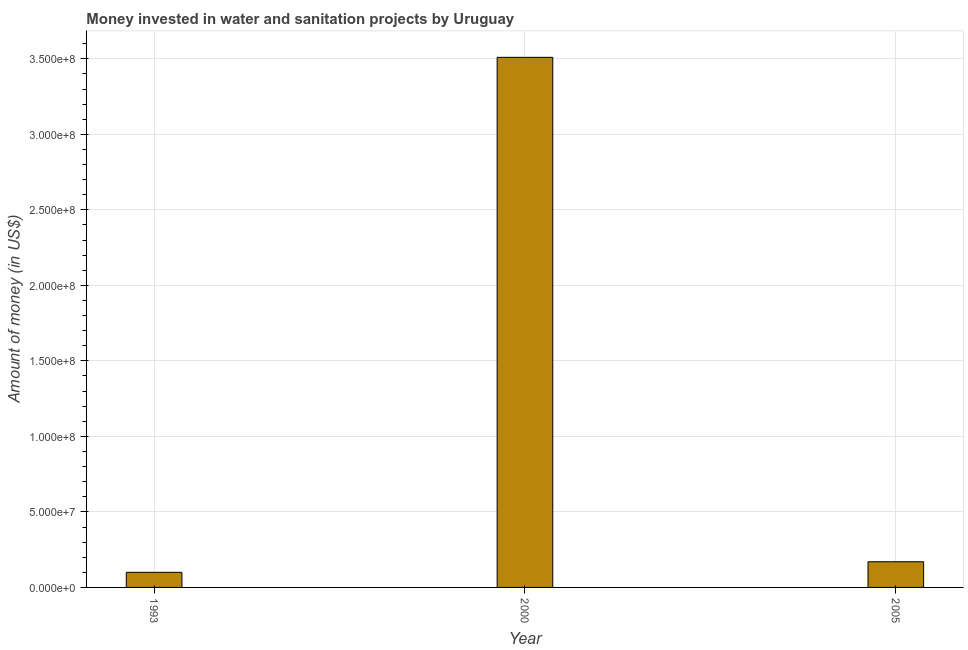Does the graph contain any zero values?
Your response must be concise. No. What is the title of the graph?
Provide a succinct answer. Money invested in water and sanitation projects by Uruguay. What is the label or title of the Y-axis?
Provide a short and direct response. Amount of money (in US$). What is the investment in 2000?
Your answer should be very brief. 3.51e+08. Across all years, what is the maximum investment?
Provide a short and direct response. 3.51e+08. In which year was the investment maximum?
Your response must be concise. 2000. In which year was the investment minimum?
Keep it short and to the point. 1993. What is the sum of the investment?
Keep it short and to the point. 3.78e+08. What is the difference between the investment in 1993 and 2000?
Your answer should be compact. -3.41e+08. What is the average investment per year?
Ensure brevity in your answer.  1.26e+08. What is the median investment?
Your answer should be compact. 1.70e+07. In how many years, is the investment greater than 300000000 US$?
Your response must be concise. 1. What is the ratio of the investment in 1993 to that in 2005?
Offer a very short reply. 0.59. Is the investment in 1993 less than that in 2000?
Give a very brief answer. Yes. What is the difference between the highest and the second highest investment?
Provide a succinct answer. 3.34e+08. Is the sum of the investment in 1993 and 2000 greater than the maximum investment across all years?
Ensure brevity in your answer.  Yes. What is the difference between the highest and the lowest investment?
Offer a terse response. 3.41e+08. In how many years, is the investment greater than the average investment taken over all years?
Provide a succinct answer. 1. How many bars are there?
Your response must be concise. 3. Are all the bars in the graph horizontal?
Your answer should be compact. No. What is the difference between two consecutive major ticks on the Y-axis?
Your answer should be compact. 5.00e+07. What is the Amount of money (in US$) in 2000?
Offer a very short reply. 3.51e+08. What is the Amount of money (in US$) in 2005?
Keep it short and to the point. 1.70e+07. What is the difference between the Amount of money (in US$) in 1993 and 2000?
Make the answer very short. -3.41e+08. What is the difference between the Amount of money (in US$) in 1993 and 2005?
Your answer should be very brief. -7.00e+06. What is the difference between the Amount of money (in US$) in 2000 and 2005?
Provide a succinct answer. 3.34e+08. What is the ratio of the Amount of money (in US$) in 1993 to that in 2000?
Make the answer very short. 0.03. What is the ratio of the Amount of money (in US$) in 1993 to that in 2005?
Your answer should be compact. 0.59. What is the ratio of the Amount of money (in US$) in 2000 to that in 2005?
Offer a terse response. 20.65. 